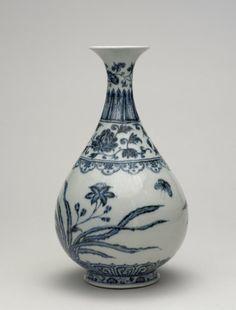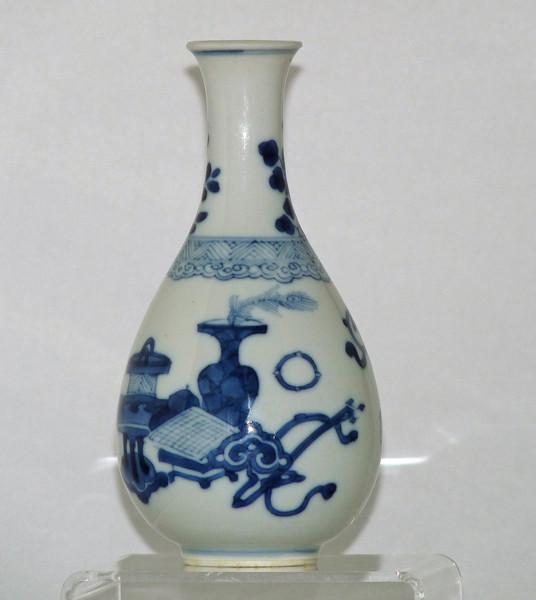The first image is the image on the left, the second image is the image on the right. For the images shown, is this caption "Each image contains a single white vase with blue decoration, and no vase has a cover." true? Answer yes or no. Yes. The first image is the image on the left, the second image is the image on the right. Evaluate the accuracy of this statement regarding the images: "The vase in the image on the right has a bulb shaped neck.". Is it true? Answer yes or no. No. 